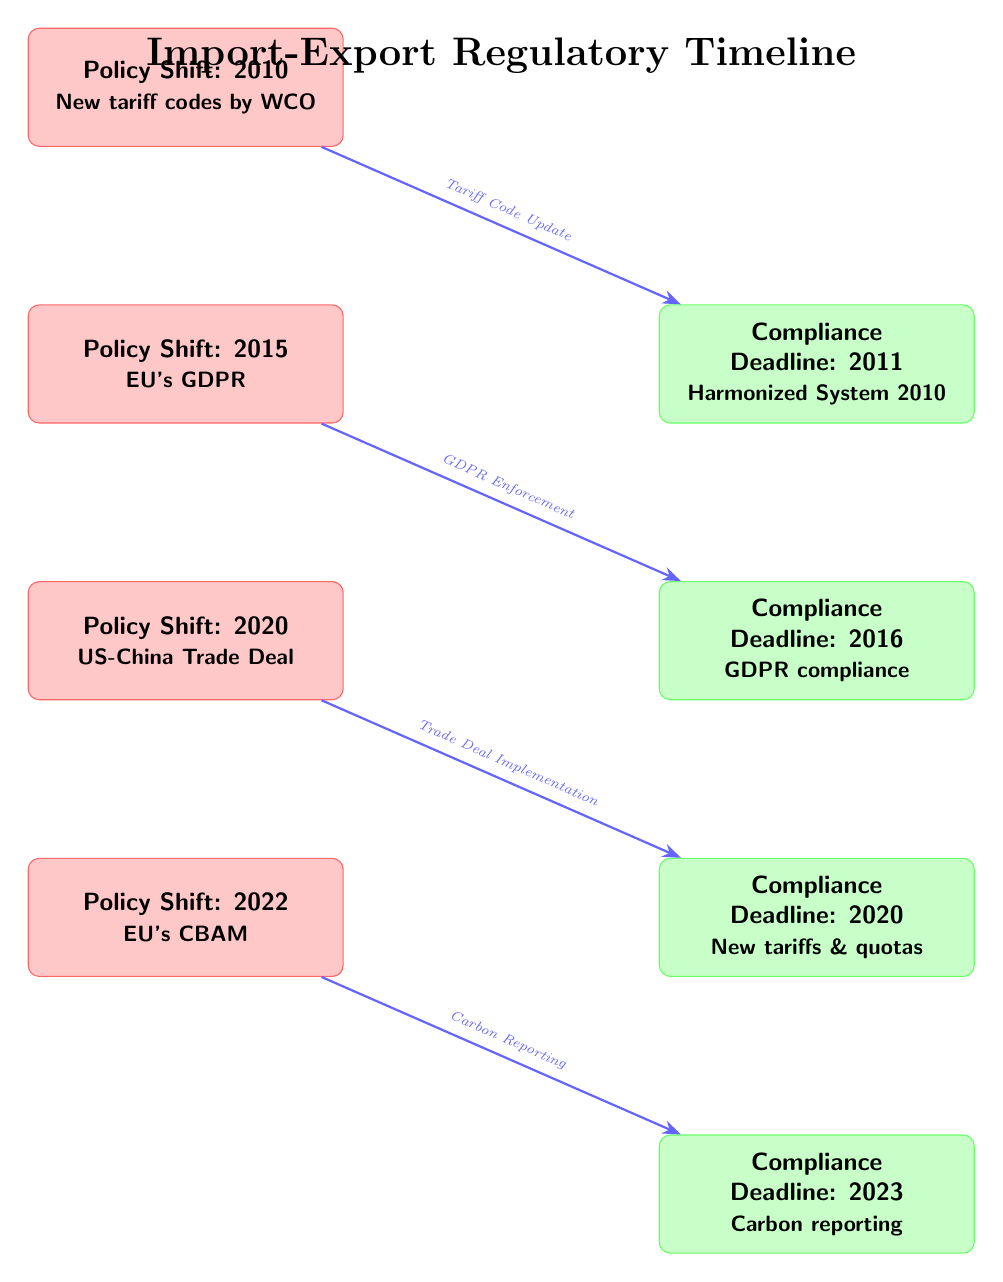What is the first policy shift noted in the diagram? The diagram starts with a policy shift labeled "Policy Shift: 2010," indicating this is the first event in the timeline.
Answer: Policy Shift: 2010 How many compliance deadlines are shown in the diagram? There are four compliance deadlines listed in the diagram corresponding to the policy shifts, which makes the total count four.
Answer: 4 What is the compliance deadline related to the GDPR? The compliance deadline associated with the GDPR, which follows the policy shift in 2015, is listed as "Compliance Deadline: 2016."
Answer: Compliance Deadline: 2016 Which policy shift is connected to carbon reporting? The diagram indicates that the policy shift associated with carbon reporting is "Policy Shift: 2022," leading into the compliance deadline for carbon reporting in 2023.
Answer: Policy Shift: 2022 What is the relationship between the 2010 policy shift and its compliance deadline? The 2010 policy shift leads directly to a compliance deadline in 2011, showing that the deadline is a direct result of the policy update for that year.
Answer: Compliance Deadline: 2011 How many total policy shifts are represented in the timeline? The diagram depicts a total of five policy shifts, which are clearly marked, indicating significant regulatory changes over the years.
Answer: 5 What enforcement action follows the 2015 policy shift? The enforcement action that correlates with the 2015 policy shift deals with GDPR compliance, which mandates adherence to new regulations.
Answer: GDPR Enforcement What is the last compliance deadline mentioned in the diagram? The final compliance deadline represented in the diagram is for 2023, which is linked to the carbon reporting requirements established by the 2022 policy shift.
Answer: Compliance Deadline: 2023 Which policy shift introduced new tariffs and quotas? The introduction of new tariffs and quotas is indicated by the policy shift labeled "Policy Shift: 2020," connecting directly to the compliance deadline of the same year.
Answer: Policy Shift: 2020 